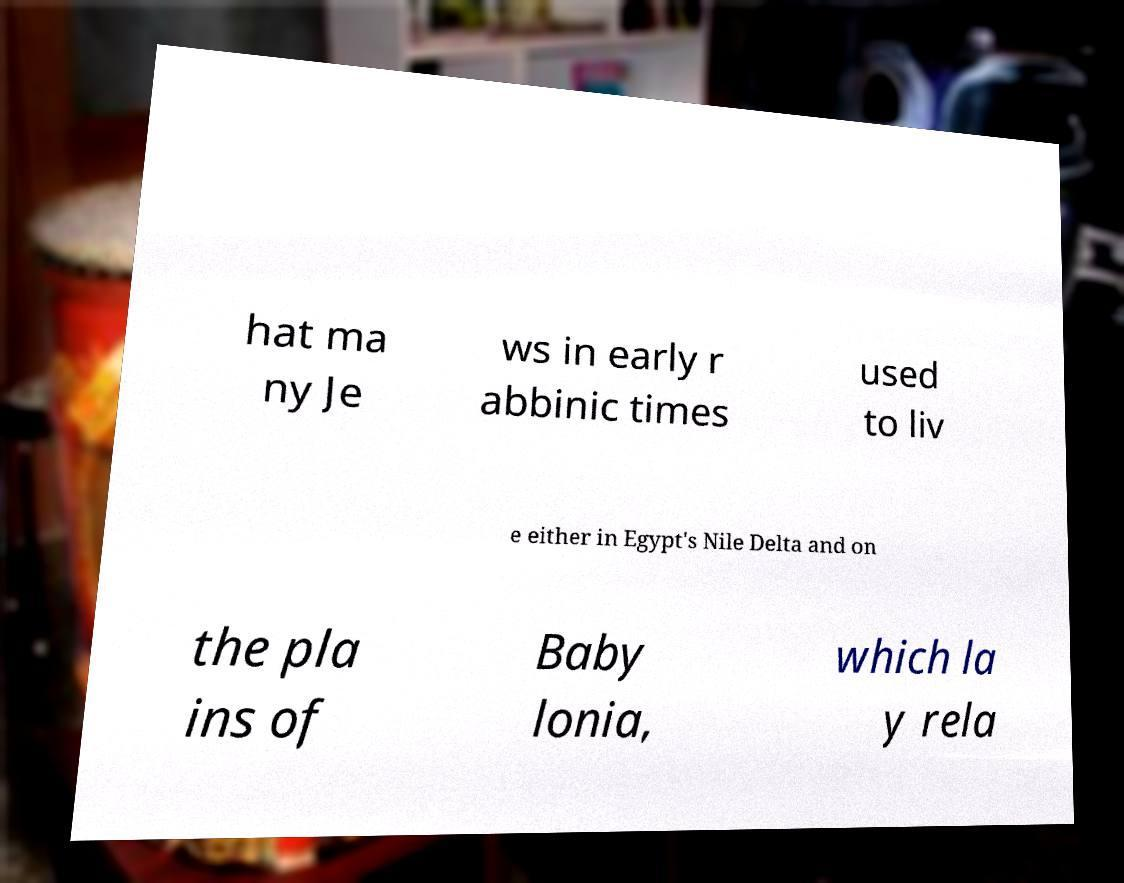Please identify and transcribe the text found in this image. hat ma ny Je ws in early r abbinic times used to liv e either in Egypt's Nile Delta and on the pla ins of Baby lonia, which la y rela 